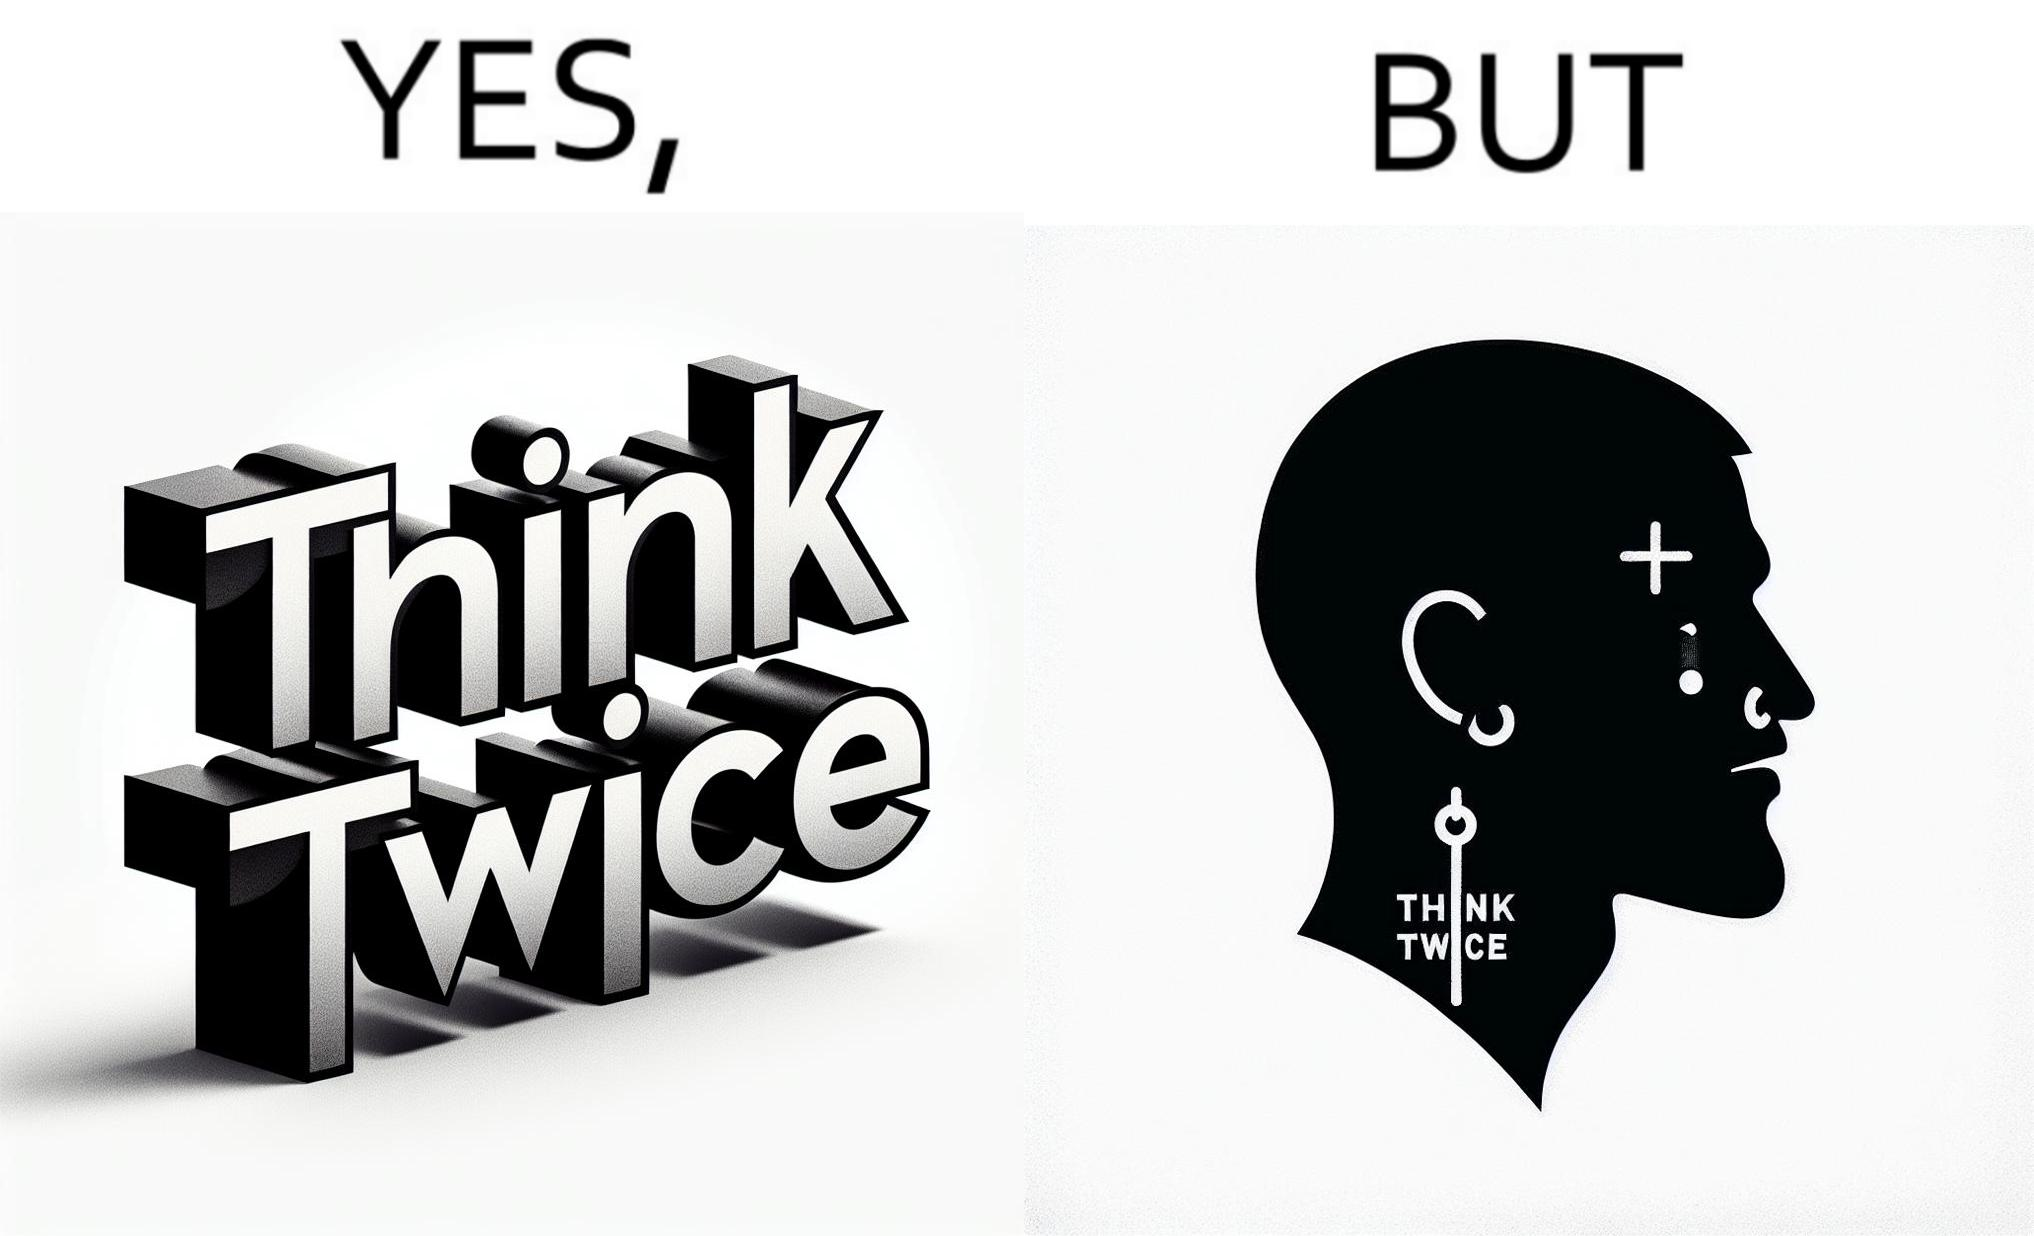Does this image contain satire or humor? Yes, this image is satirical. 